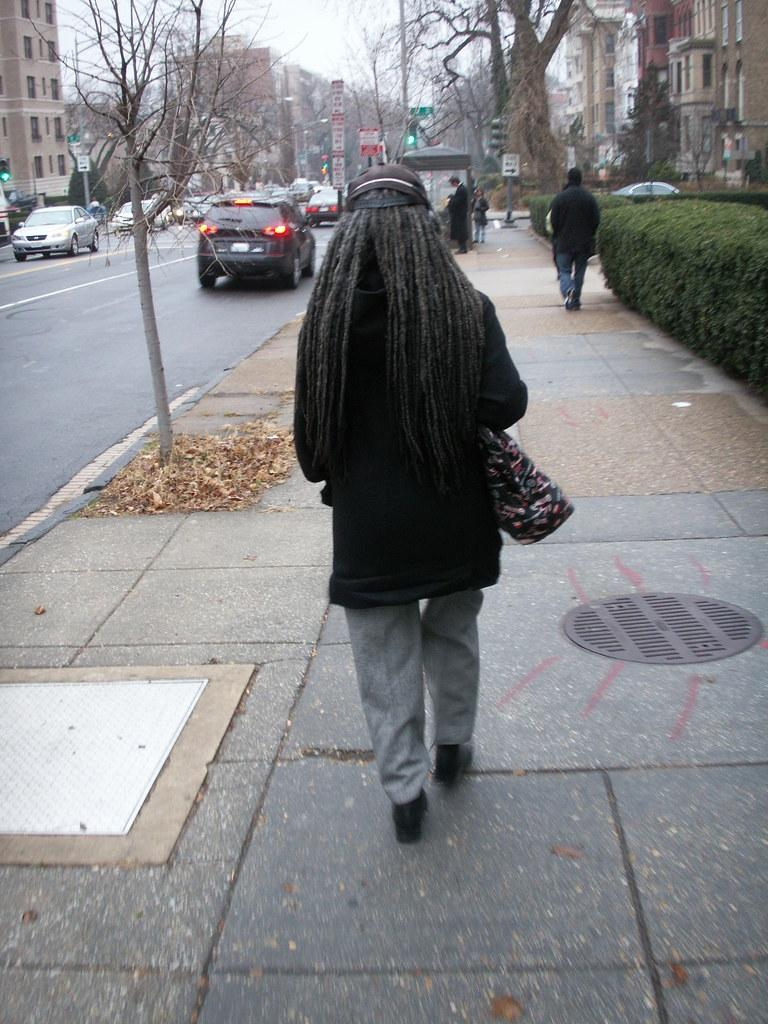How many people are in the image? There are people in the image, but the exact number is not specified. What types of vehicles can be seen in the image? There are vehicles in the image, but the specific types are not mentioned. What is the primary feature of the image? The primary feature of the image is a road. What other objects can be seen in the image besides people and vehicles? In addition to people and vehicles, there are boards, poles, plants, bare trees, and buildings in the image. What can be seen in the background of the image? The sky is visible in the background of the image. Where is the sink located in the image? There is no sink present in the image. What type of hose is being used by the government in the image? There is no hose or government involvement depicted in the image. 